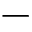Convert formula to latex. <formula><loc_0><loc_0><loc_500><loc_500>-</formula> 